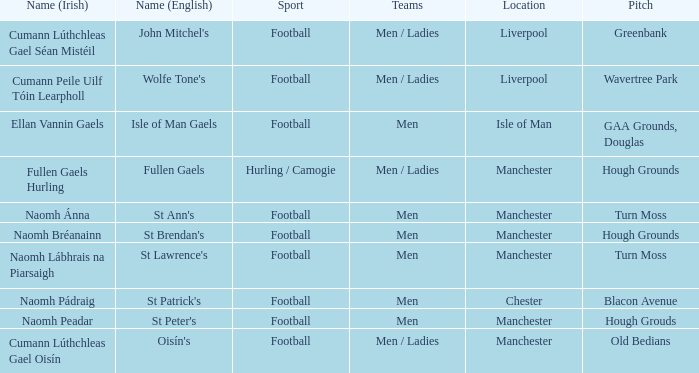Where can the old bedians pitch be found? Manchester. Could you help me parse every detail presented in this table? {'header': ['Name (Irish)', 'Name (English)', 'Sport', 'Teams', 'Location', 'Pitch'], 'rows': [['Cumann Lúthchleas Gael Séan Mistéil', "John Mitchel's", 'Football', 'Men / Ladies', 'Liverpool', 'Greenbank'], ['Cumann Peile Uilf Tóin Learpholl', "Wolfe Tone's", 'Football', 'Men / Ladies', 'Liverpool', 'Wavertree Park'], ['Ellan Vannin Gaels', 'Isle of Man Gaels', 'Football', 'Men', 'Isle of Man', 'GAA Grounds, Douglas'], ['Fullen Gaels Hurling', 'Fullen Gaels', 'Hurling / Camogie', 'Men / Ladies', 'Manchester', 'Hough Grounds'], ['Naomh Ánna', "St Ann's", 'Football', 'Men', 'Manchester', 'Turn Moss'], ['Naomh Bréanainn', "St Brendan's", 'Football', 'Men', 'Manchester', 'Hough Grounds'], ['Naomh Lábhrais na Piarsaigh', "St Lawrence's", 'Football', 'Men', 'Manchester', 'Turn Moss'], ['Naomh Pádraig', "St Patrick's", 'Football', 'Men', 'Chester', 'Blacon Avenue'], ['Naomh Peadar', "St Peter's", 'Football', 'Men', 'Manchester', 'Hough Grouds'], ['Cumann Lúthchleas Gael Oisín', "Oisín's", 'Football', 'Men / Ladies', 'Manchester', 'Old Bedians']]} 